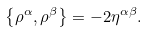<formula> <loc_0><loc_0><loc_500><loc_500>\left \{ \rho ^ { \alpha } , \rho ^ { \beta } \right \} = - 2 \eta ^ { \alpha \beta } .</formula> 